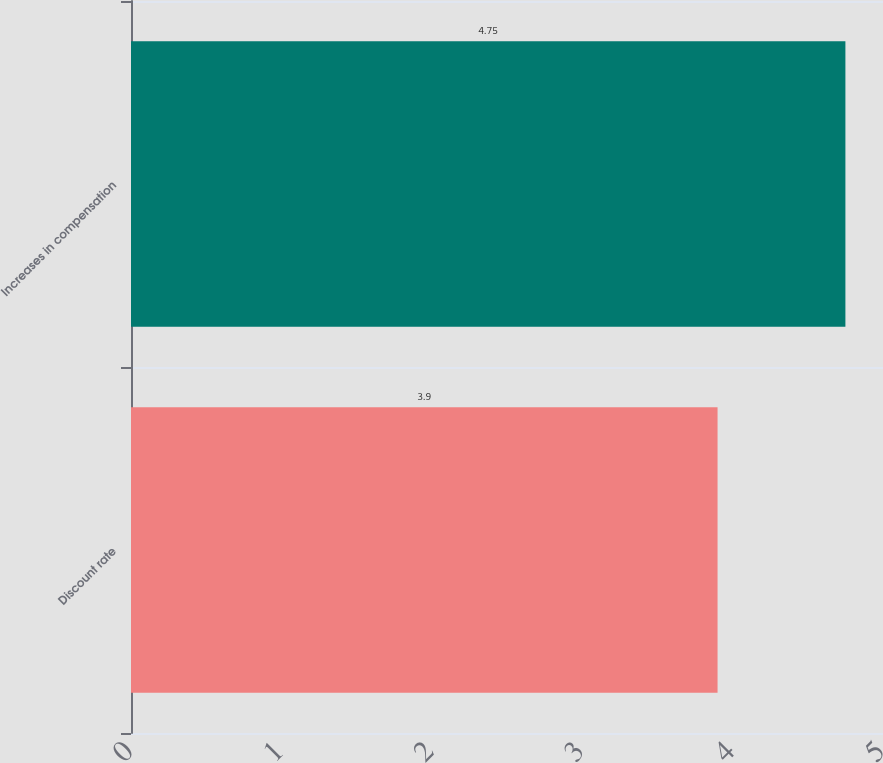Convert chart to OTSL. <chart><loc_0><loc_0><loc_500><loc_500><bar_chart><fcel>Discount rate<fcel>Increases in compensation<nl><fcel>3.9<fcel>4.75<nl></chart> 